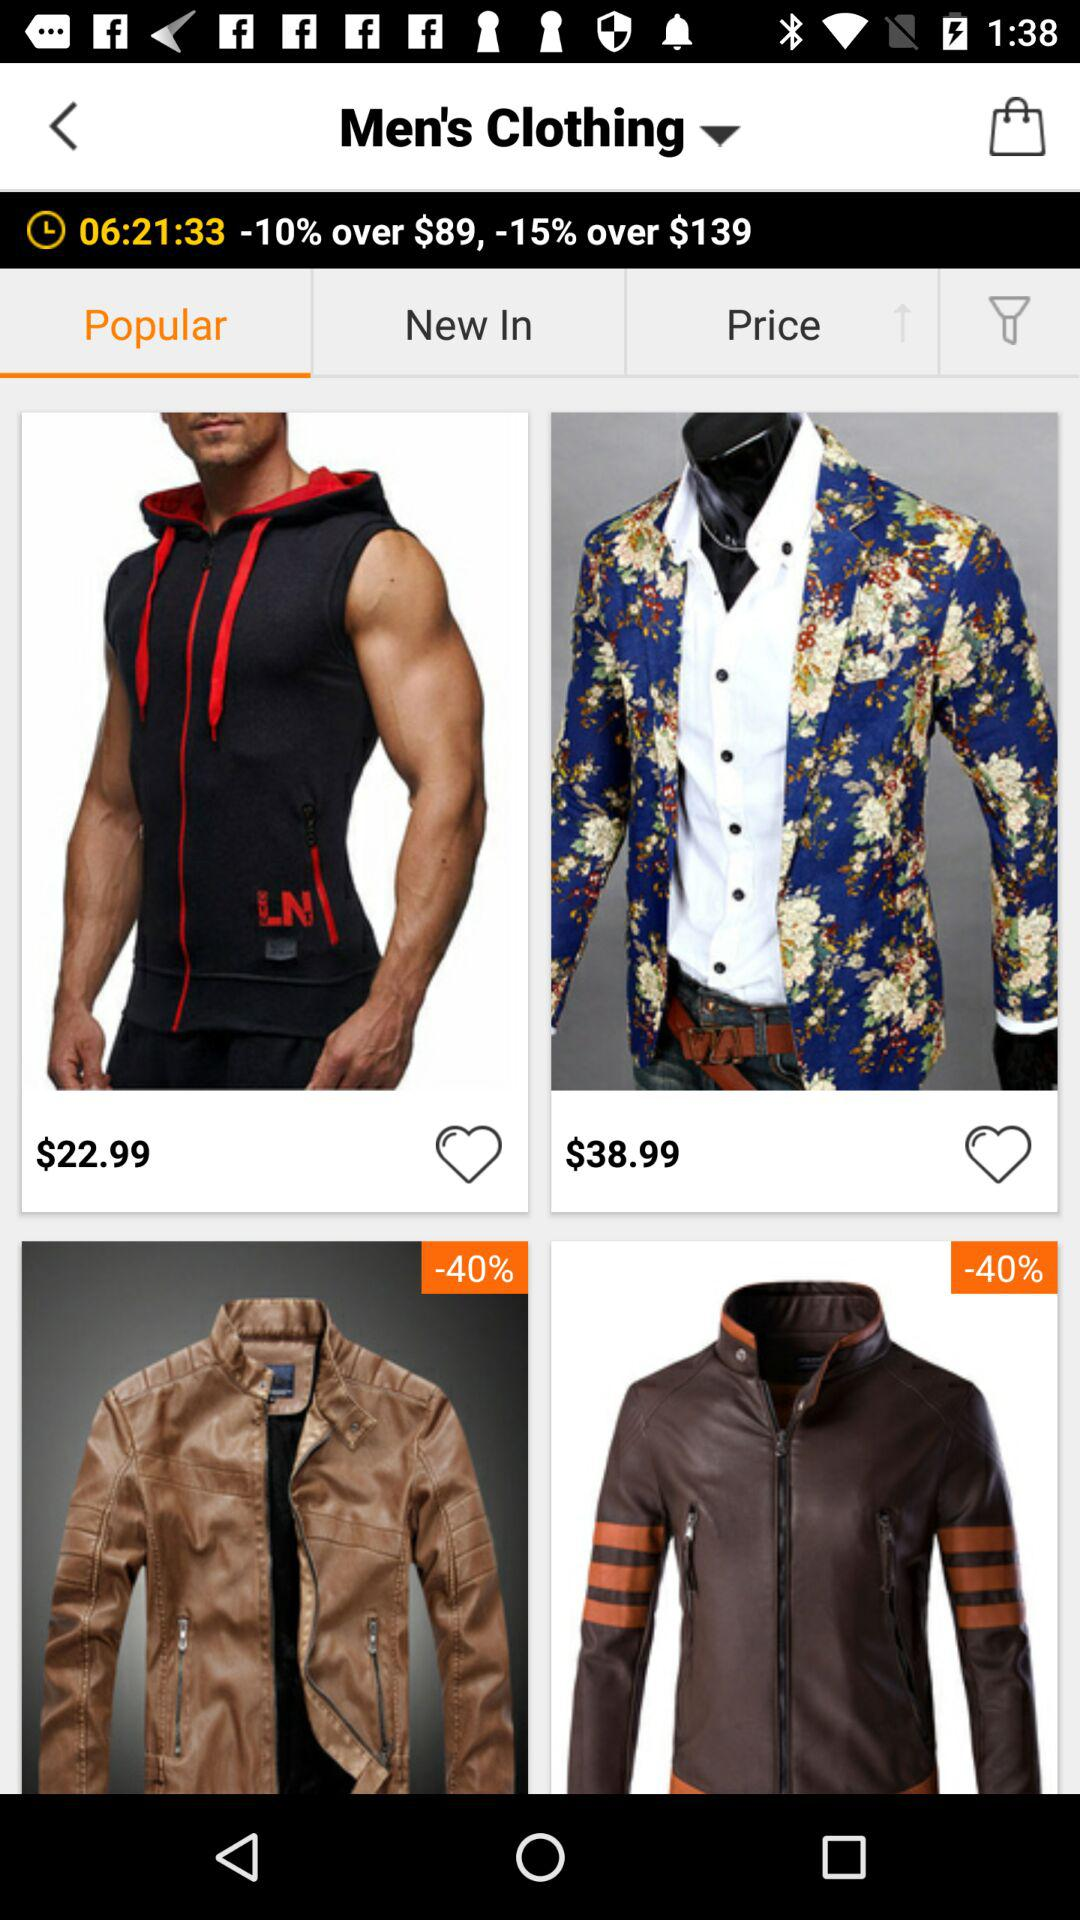How much discount will we get after shopping for more than $139? You will get a 15% discount. 